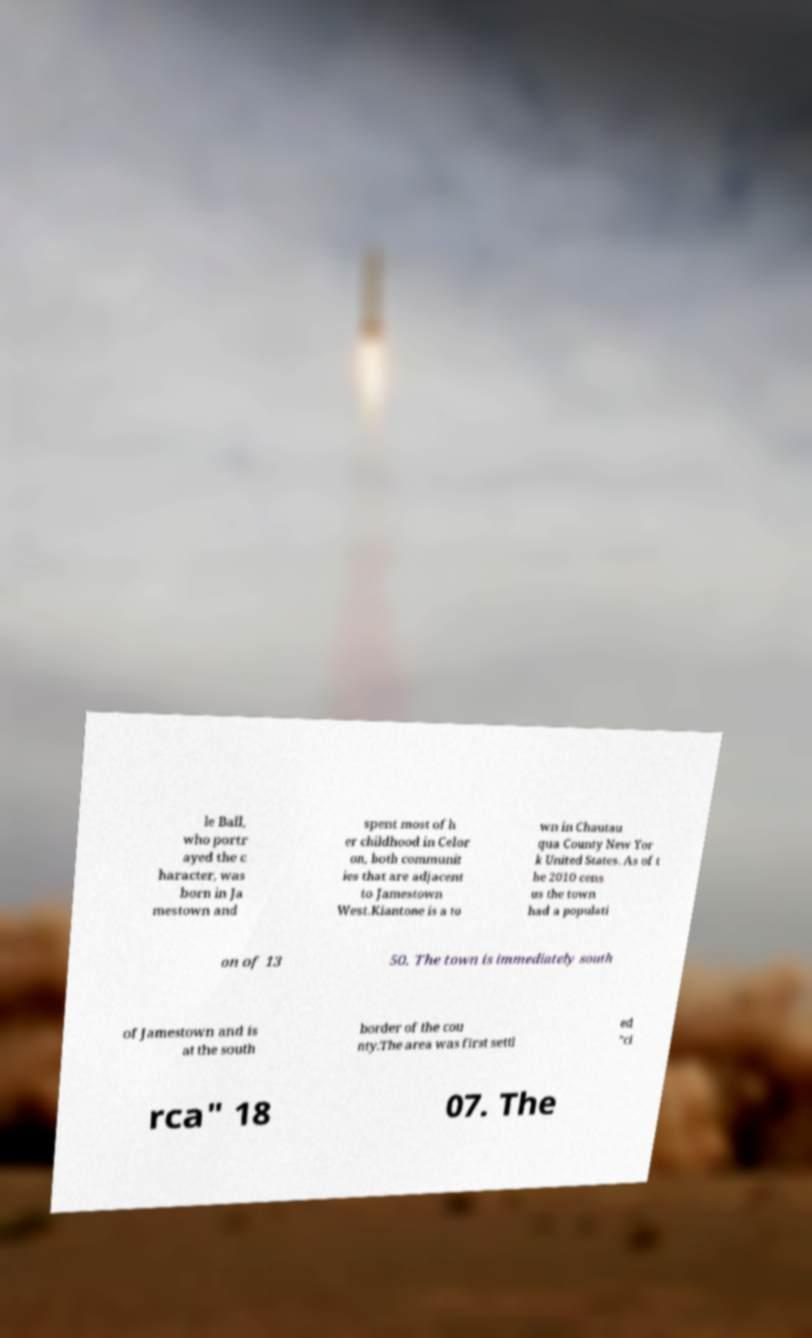Please identify and transcribe the text found in this image. le Ball, who portr ayed the c haracter, was born in Ja mestown and spent most of h er childhood in Celor on, both communit ies that are adjacent to Jamestown West.Kiantone is a to wn in Chautau qua County New Yor k United States. As of t he 2010 cens us the town had a populati on of 13 50. The town is immediately south of Jamestown and is at the south border of the cou nty.The area was first settl ed "ci rca" 18 07. The 